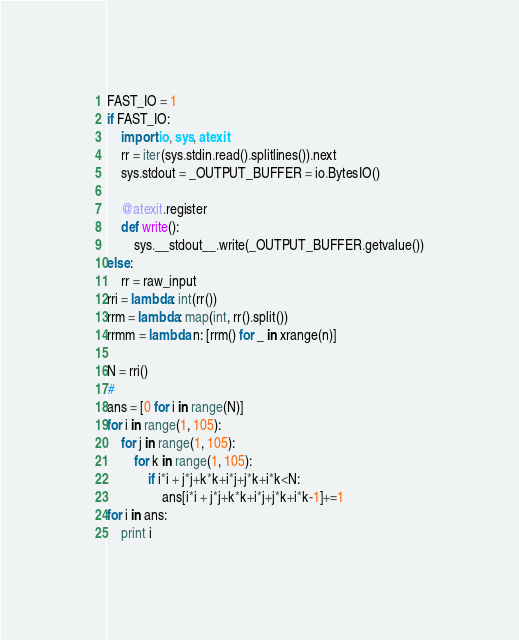<code> <loc_0><loc_0><loc_500><loc_500><_Python_>FAST_IO = 1
if FAST_IO:
    import io, sys, atexit
    rr = iter(sys.stdin.read().splitlines()).next
    sys.stdout = _OUTPUT_BUFFER = io.BytesIO()

    @atexit.register
    def write():
        sys.__stdout__.write(_OUTPUT_BUFFER.getvalue())
else:
    rr = raw_input
rri = lambda: int(rr())
rrm = lambda: map(int, rr().split())
rrmm = lambda n: [rrm() for _ in xrange(n)]

N = rri()
# 
ans = [0 for i in range(N)]
for i in range(1, 105):
    for j in range(1, 105):
        for k in range(1, 105):
            if i*i + j*j+k*k+i*j+j*k+i*k<N:
                ans[i*i + j*j+k*k+i*j+j*k+i*k-1]+=1
for i in ans:
    print i
</code> 